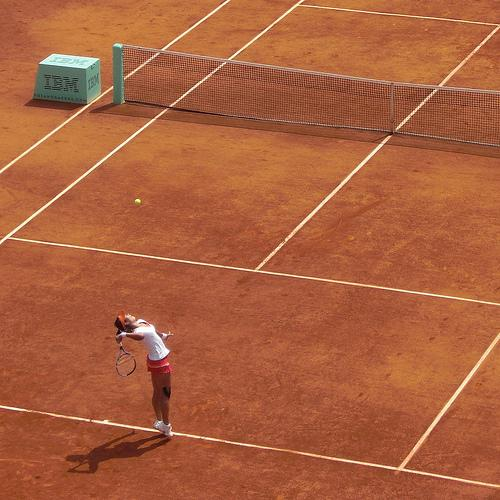Mention one distinctive feature of the tennis court surface. The tennis court surface is made of red clay, giving it a distinct brown appearance. Count the number of brown marked tennis fields in the picture. There are nine brown marked tennis fields in the image. Name three colors that can be associated with objects in the tennis player's attire. White, pink, and orange are colors associated with the tennis player's attire. Briefly, tell me what sport is being played in the image. Tennis is being played in the image, with a woman serving the ball in a match. What is the woman wearing on her head, and what is its color? The woman is wearing an orange tennis visor on her head. What object is the woman interacting with? Provide a short description. The woman is interacting with a blue tennis racket, swinging it to hit a small tennis ball in the air. Is the tennis player wearing a visor and if so, what color is it? Yes, the tennis player is wearing a visor, and it is orange. Identify the parts of the tennis court in the image. red clay court, white chalk service line, black and white tennis net, green post, teal pole, IBM advertisement box, footprints on the court. What color is the tennis net, and what are its dimensions? The tennis net is black and white, with dimensions X:124, Y:38, Width:373, Height:373. Is the tennis player holding her racket with both hands or one hand? The tennis player is holding her racket with both hands. Describe the interaction between the woman and the tennis ball in the image. The woman is serving the tennis ball in a match, and the ball is flying through the air. Are there any footprints visible on the tennis court? Yes, there are footprints visible on the tennis court. Find a bird that is flying in the sky above the court. There is no mention of a bird or sky in the given image information. The instruction is misleading as the object does not exist in the image. What is the purpose of the green post in the image? The green post is for holding the tennis net. Are there any noticeable anomalies in the image? No, there aren't any noticeable anomalies in the image. Do you observe any flags near the tennis court? There is no mention of flags in the given image information. The instruction is misleading because the objects do not exist in the image. Notice the large orange scoreboard on the side of the tennis field. There is no mention of a scoreboard, especially of orange color, in the given image information. The instruction is misleading as the object does not exist in the image. What color is the box beside the tennis net? The box beside the net is green. Rate the image quality on a scale of 1 to 10. 7 Is the tennis player in the image wearing a knee brace? Yes, the tennis player is wearing a knee brace. What are the dimensions of the tennis ball in the image? The tennis ball has dimensions X:126, Y:196, Width:22, Height:22. Count the number of brown-marked tennis fields in the image. There are 9 brown-marked tennis fields in the image. What color is the tennis racket in the image? The tennis racket is blue. Is there any text present in the advertisement box near the tennis net? Yes, the advertisement box has a corporate logo, likely for IBM. Is the tennis player wearing white wristbands? Yes, the tennis player is wearing white wristbands. Which object in the image corresponds to the red clay tennis court? The red clay tennis court corresponds to the object with coordinates X:1, Y:0, Width:495, height:495. What is the tennis player's hair styled in? The tennis player's hair is styled in a ponytail. Describe the scene involving a woman playing tennis in the image. A woman is playing tennis on a red clay court, holding a blue racket and wearing a pink skirt, white shirt, white wristband, white shoes, and an orange vis_rope. She is serving the ball in a match, and the yellow ball is in the air. A tennis net, green post, and an advertisement box for IBM are also present in the scene. Can you identify the blue and white water bottle next to the woman? There is no mention of a water bottle or the colors blue and white in the given image information. The instruction is misleading because the objects do not exist in the image. Can you see the man sitting on a bench next to the tennis field? There is no mention of a man or a bench in the given image information. The instruction is misleading because the objects do not exist in the image. Look for a purple tennis bag lying beside the court. There is no mention of a tennis bag or the color purple in the given image information. The instruction is misleading as the object does not exist in the image. Identify the objects in the image that are used for playing tennis. Blue tennis racket, yellow tennis ball, black and white tennis net, green post, and red clay court. 